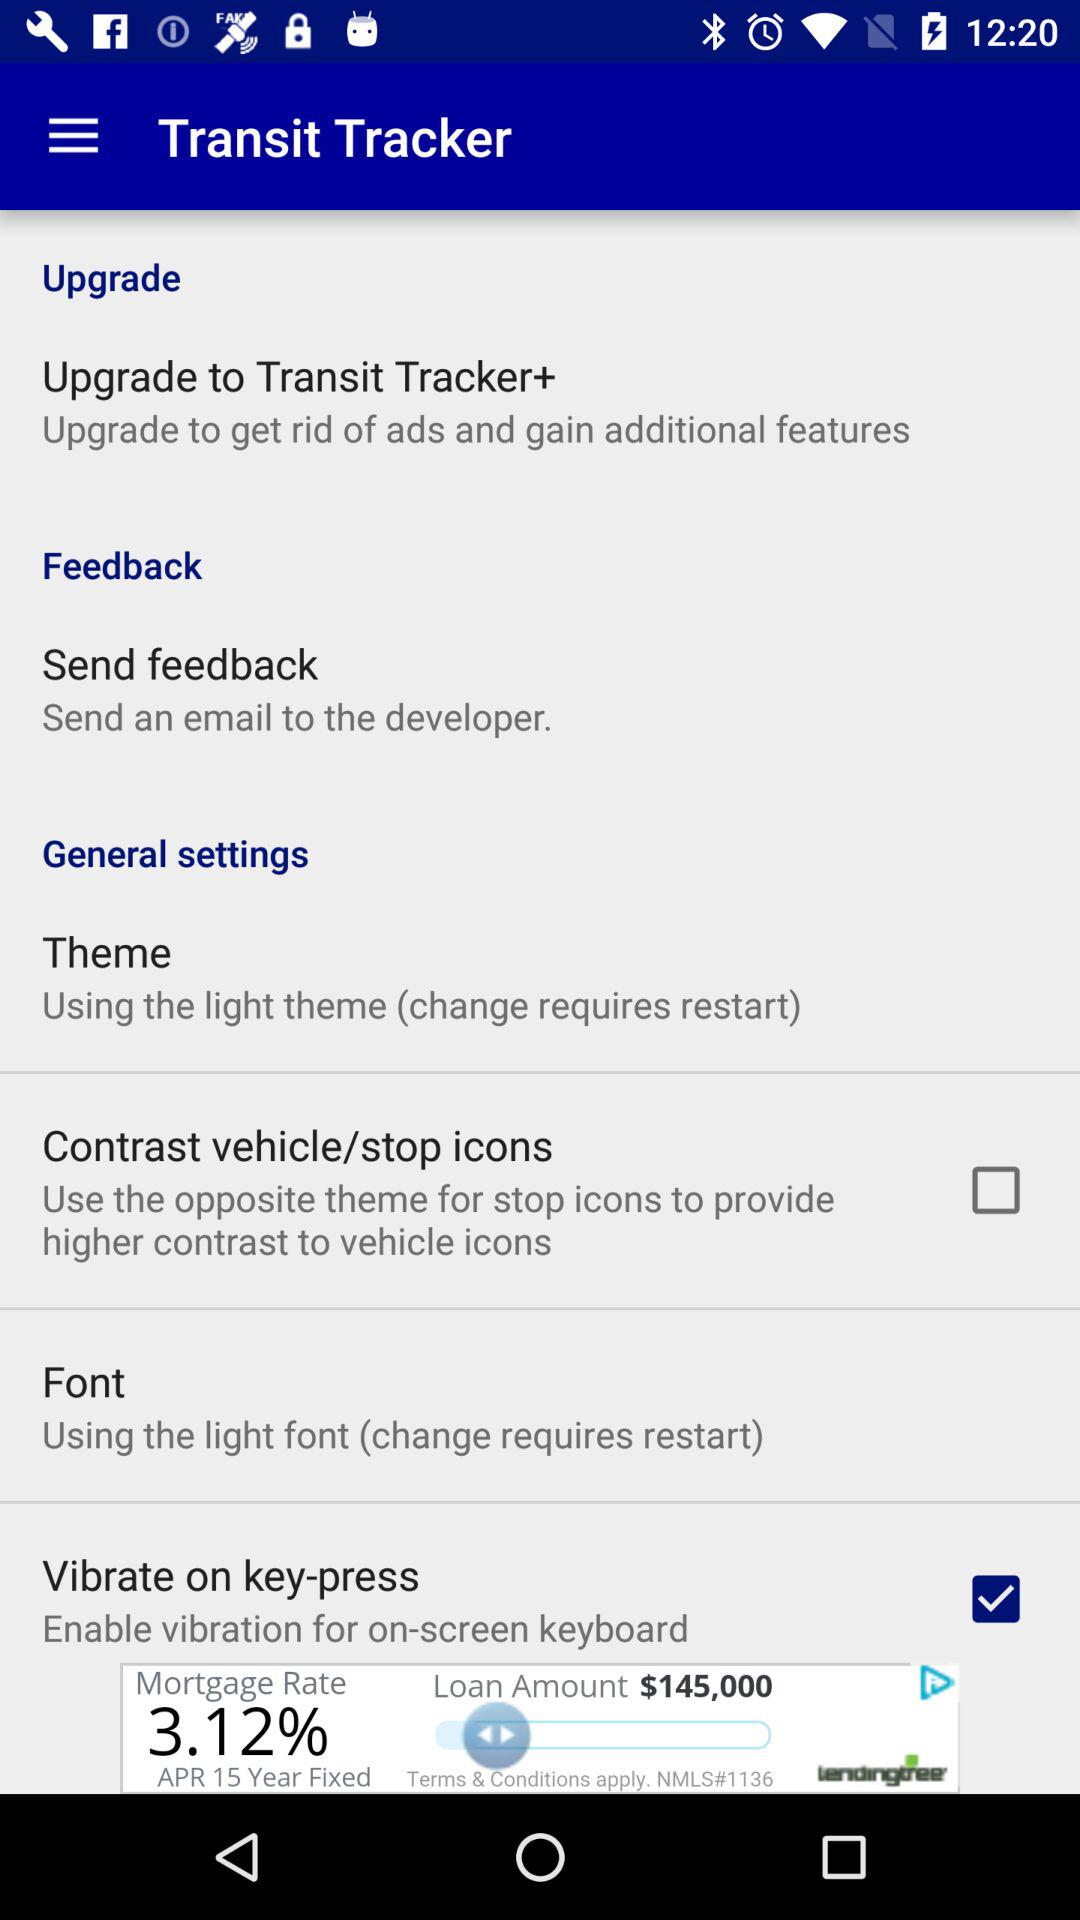How many settings are in the general settings section?
Answer the question using a single word or phrase. 4 